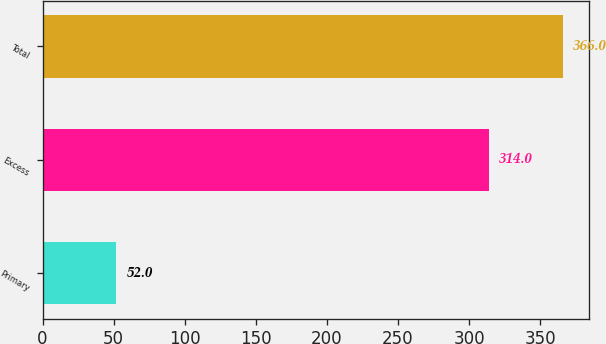Convert chart to OTSL. <chart><loc_0><loc_0><loc_500><loc_500><bar_chart><fcel>Primary<fcel>Excess<fcel>Total<nl><fcel>52<fcel>314<fcel>366<nl></chart> 